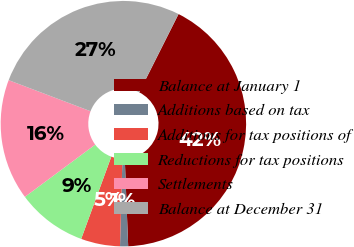Convert chart. <chart><loc_0><loc_0><loc_500><loc_500><pie_chart><fcel>Balance at January 1<fcel>Additions based on tax<fcel>Additions for tax positions of<fcel>Reductions for tax positions<fcel>Settlements<fcel>Balance at December 31<nl><fcel>41.96%<fcel>1.06%<fcel>5.15%<fcel>9.24%<fcel>15.94%<fcel>26.65%<nl></chart> 